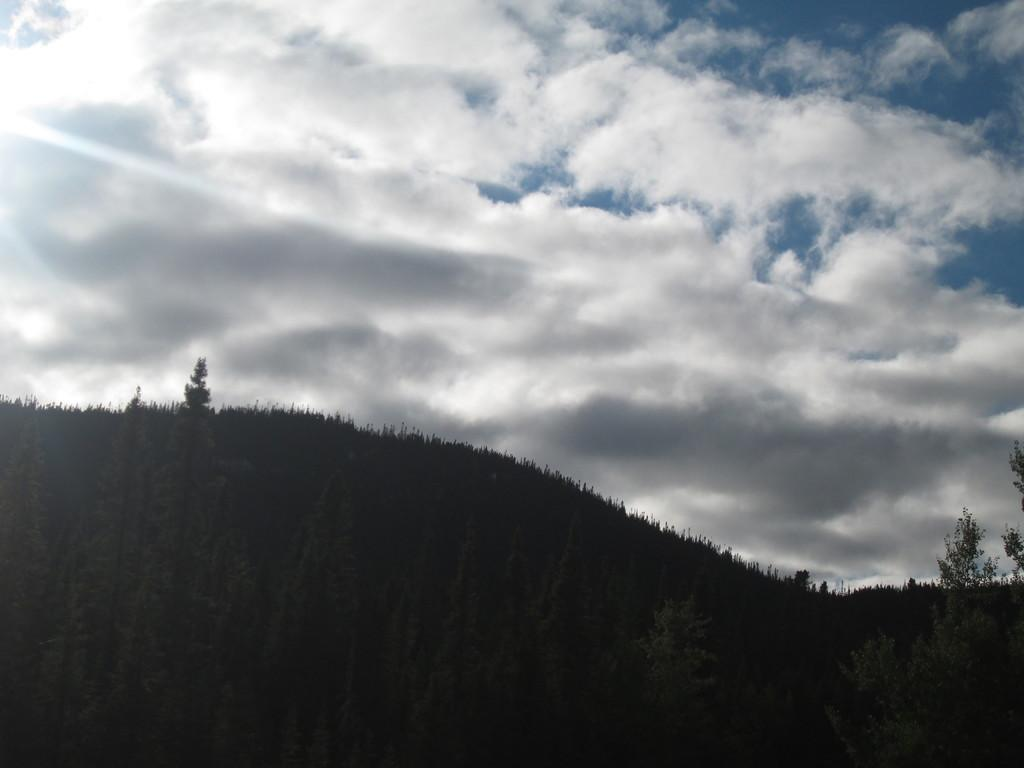What is the main geographical feature in the image? There is a mountain in the image. What type of vegetation is present at the base of the mountain? There are many trees at the bottom of the mountain. What can be seen at the top of the mountain? The sky is visible at the top of the mountain. What is the condition of the sky in the image? Clouds are present in the sky. Where is the sun located in the image? There is a sun in the top left corner of the image. What type of flesh can be seen on the mountain in the image? There is no flesh present on the mountain in the image; it is a geographical feature made of rock and vegetation. How many feet are visible on the mountain in the image? There are no feet visible on the mountain in the image; it is a geographical feature without any human or animal presence. 